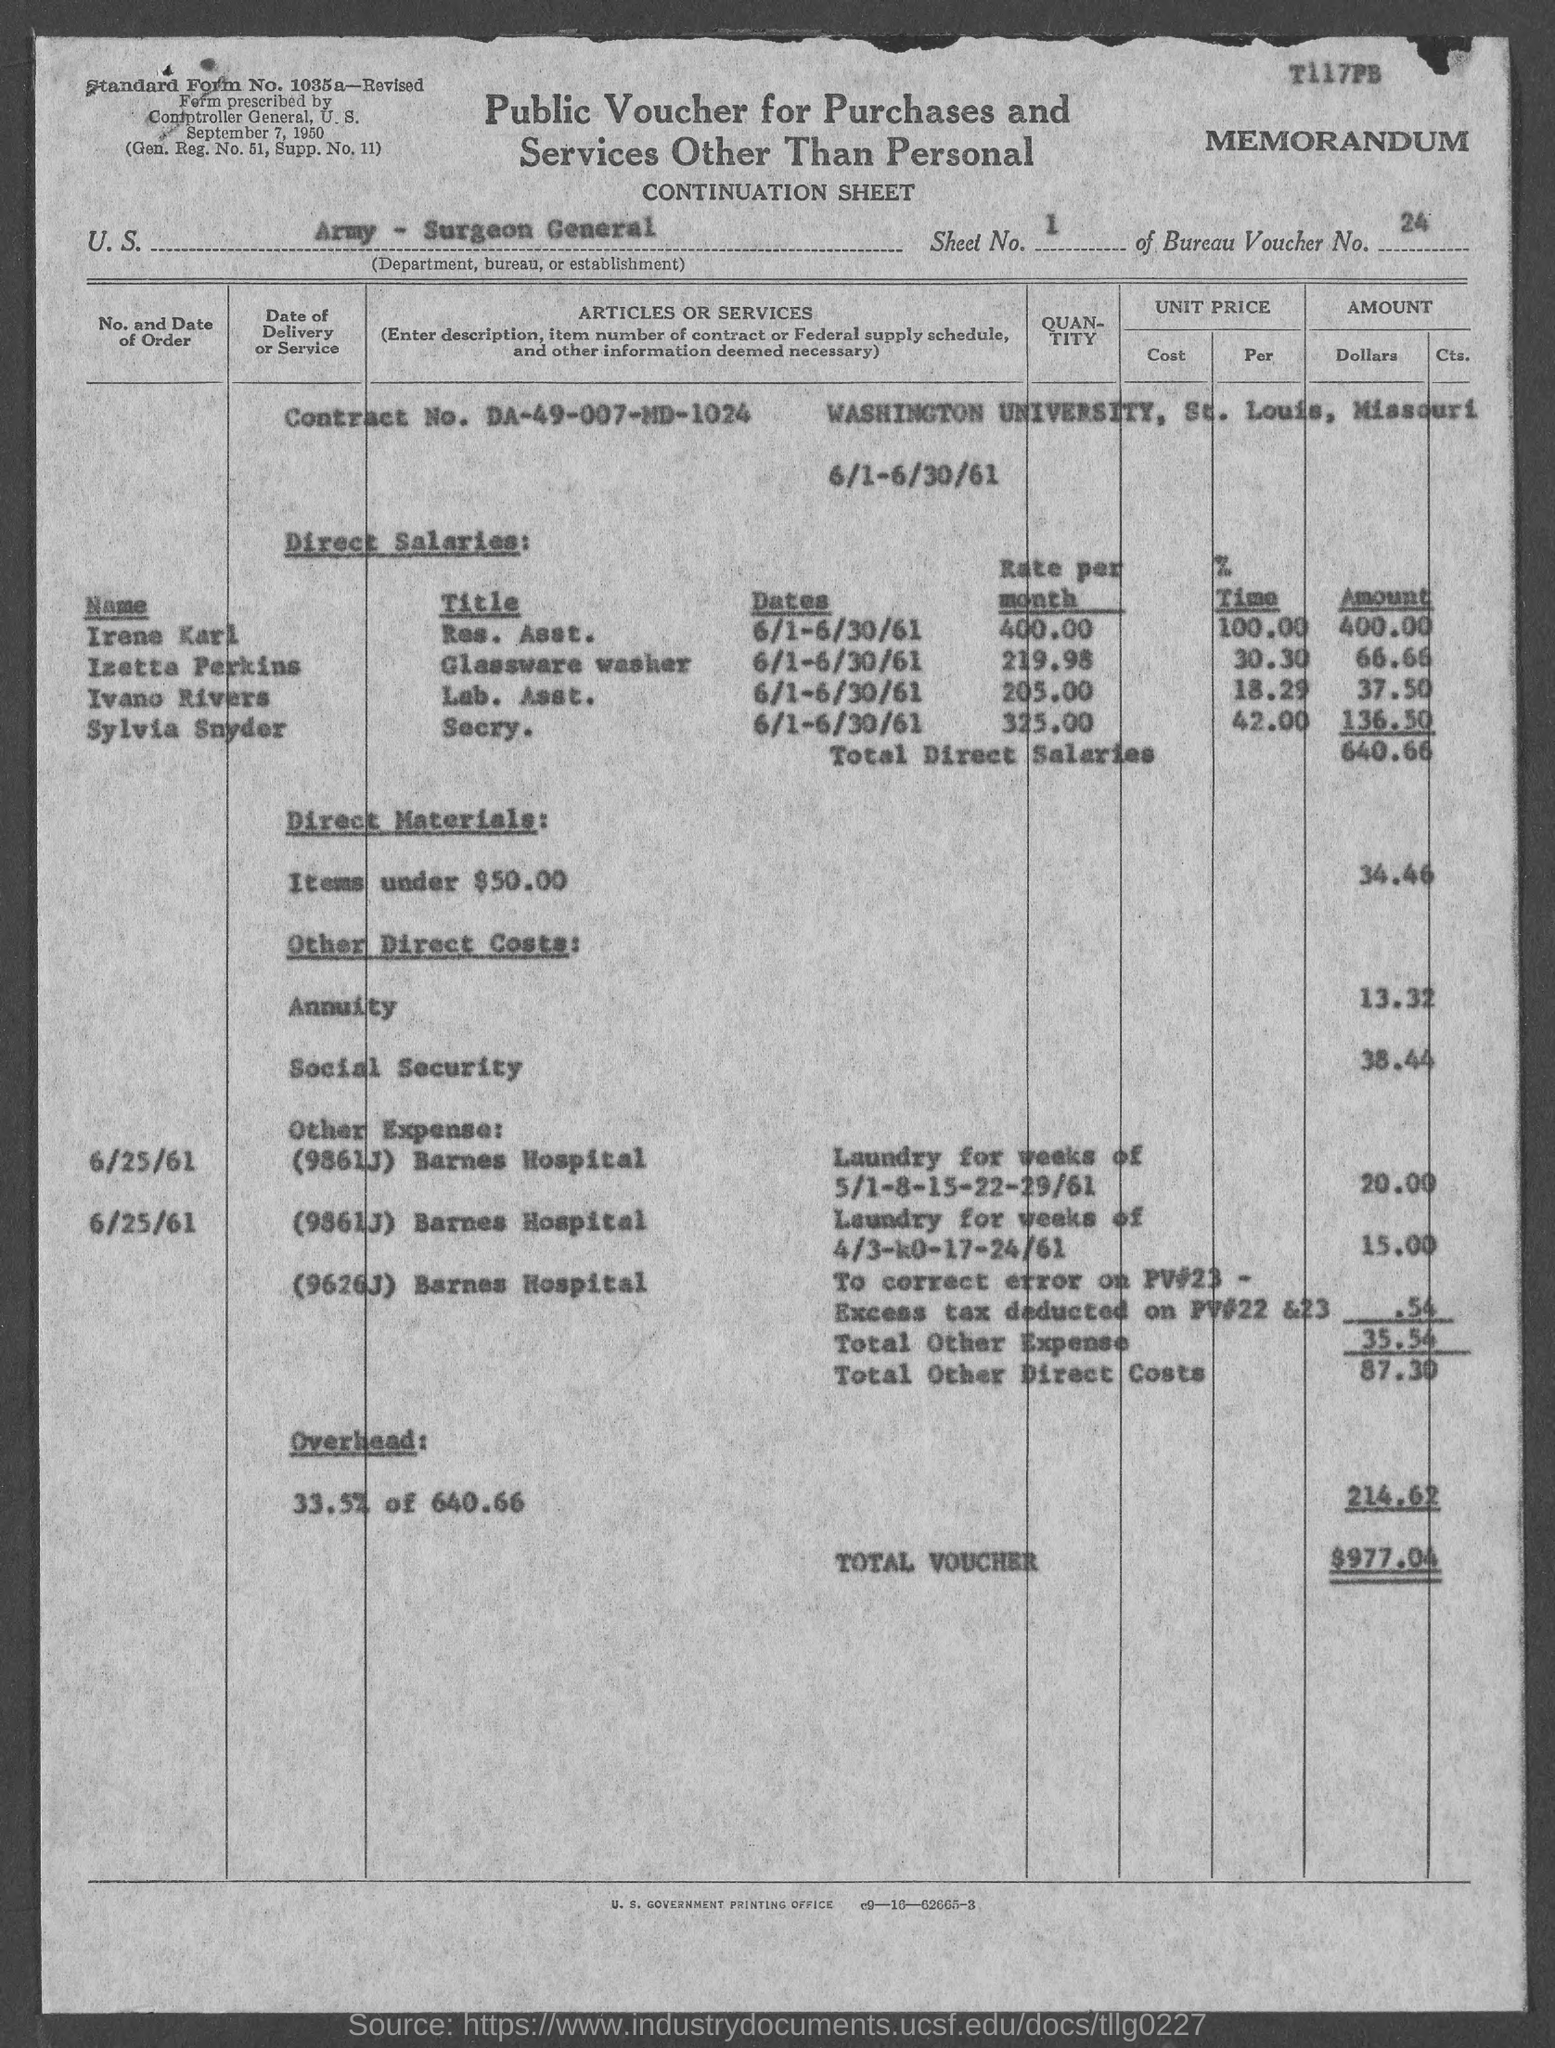What is the standard form no.?
Your answer should be very brief. 1035a. What is the sheet no.?
Make the answer very short. 1. What is the bureau voucher no.?
Provide a succinct answer. 24. What is the contract no.?
Your response must be concise. DA-49-007-MD-1024. What is the total voucher amount ?
Ensure brevity in your answer.  $ 977.04. In which state is washington university located ?
Make the answer very short. Missouri. What is the title of irene karl ?
Your answer should be very brief. Res. Asst. What is the title of izetta perkins ?
Give a very brief answer. Glassware washer. What is the title of ivano rivers ?
Keep it short and to the point. Lab. Asst. What is the title of sylvia snyder ?
Keep it short and to the point. Secry. 